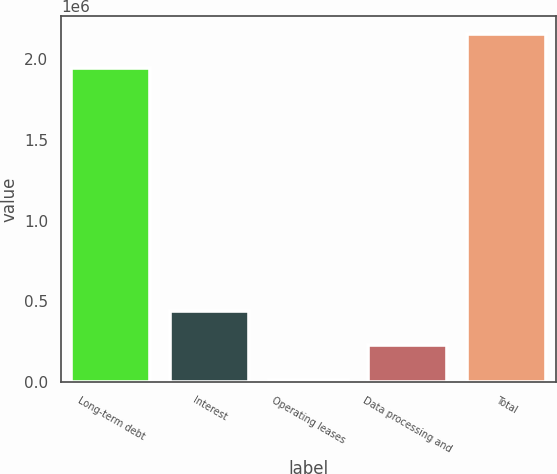Convert chart. <chart><loc_0><loc_0><loc_500><loc_500><bar_chart><fcel>Long-term debt<fcel>Interest<fcel>Operating leases<fcel>Data processing and<fcel>Total<nl><fcel>1.94503e+06<fcel>437919<fcel>14860<fcel>226389<fcel>2.15656e+06<nl></chart> 